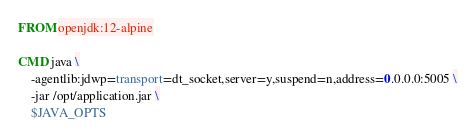Convert code to text. <code><loc_0><loc_0><loc_500><loc_500><_Dockerfile_>FROM openjdk:12-alpine

CMD java \
    -agentlib:jdwp=transport=dt_socket,server=y,suspend=n,address=0.0.0.0:5005 \
    -jar /opt/application.jar \
    $JAVA_OPTS</code> 